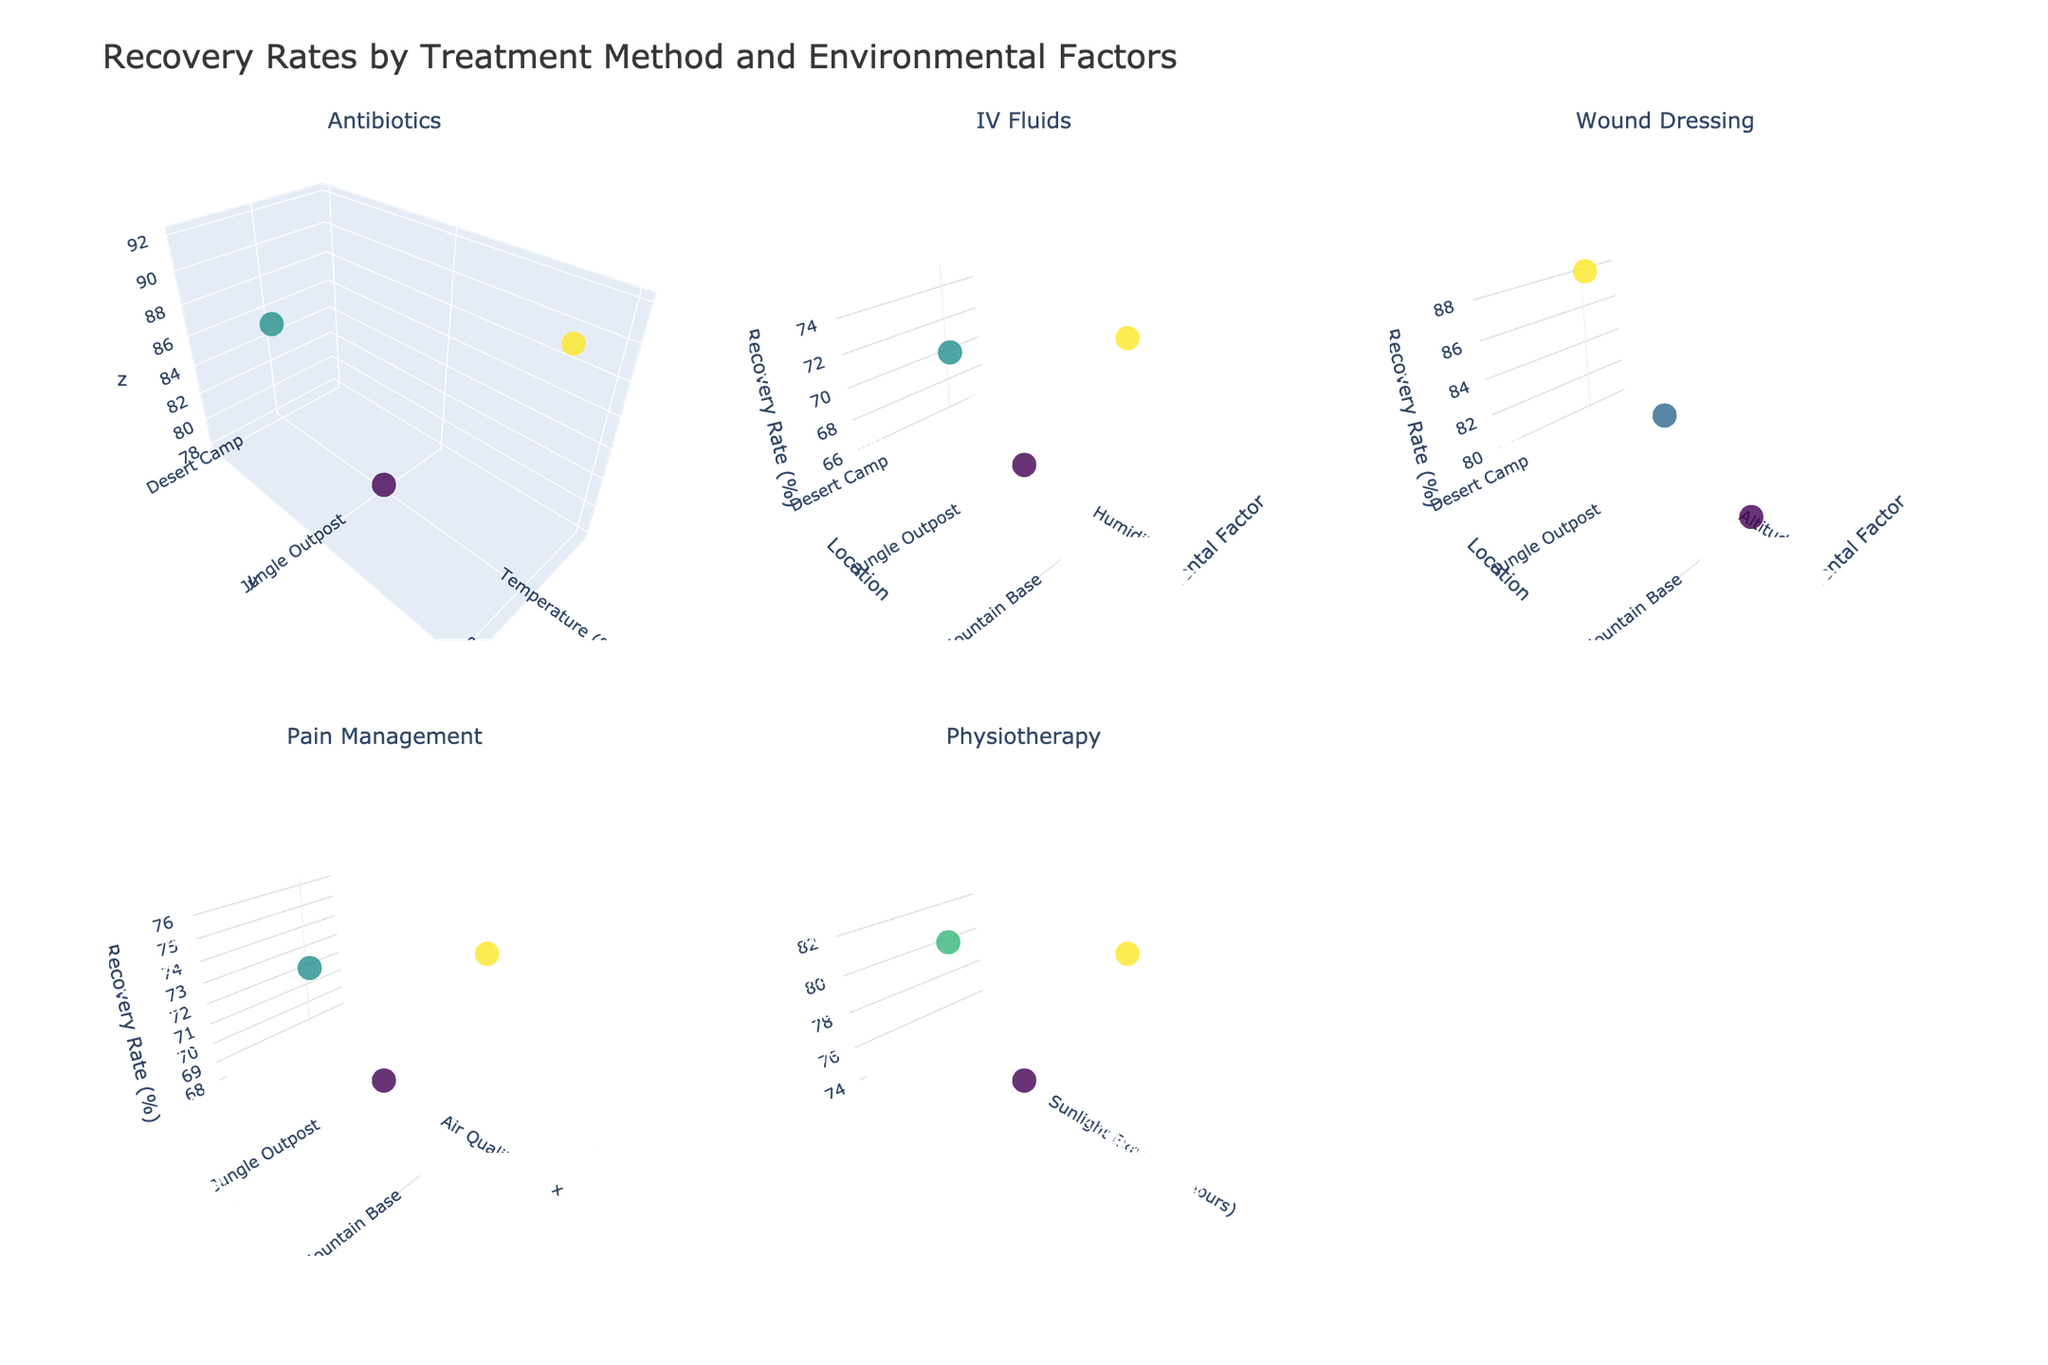What is the title of the plot? The title of the plot is usually displayed at the top of the figure. In this case, it can be found in the layout setting of the figure.
Answer: Recovery Rates by Treatment Method and Environmental Factors How many subplots are present for different treatment methods? The subplots can be identified by their separate scenes and titles. The subplot titles indicate different treatment methods.
Answer: 5 Which environmental factor is associated with the Antibiotics treatment at Jungle Outpost? By looking at the subplot titled 'Antibiotics' for the point labeled Jungle Outpost, we can find the associated environmental factor.
Answer: Temperature (°C) Which treatment method shows the highest recovery rate in the Mountain Base location? By examining each subplot and identifying the highest data point in the Mountain Base location, we can determine which treatment method it corresponds to.
Answer: Antibiotics Compare the recovery rates between Jungle Outpost and Mountain Base for Pain Management. Which location has higher recovery rates? By observing the contrast in z-values on the subplot titled 'Pain Management' between Jungle Outpost and Mountain Base, we can see which is higher.
Answer: Mountain Base What is the average recovery rate across all locations for Physiotherapy? Adding up the recovery rates for Physiotherapy at each location and dividing by the number of locations gives us the average.
Answer: (80 + 74 + 83) / 3 = 79 For IV Fluids, which location has the lowest recovery rate and what is its rate? By comparing the z-values in the IV Fluids subplot, we identify the location with the lowest rate and then check its value.
Answer: Jungle Outpost, 65 Is there any treatment method where all locations have similar recovery rates? By evaluating the spread of data points in each subplot, we can determine if any treatment method shows little variability across locations.
Answer: IV Fluids What is the environmental factor influencing recovery rates in the subplot for Wound Dressing? The environmental factor for the Wound Dressing subplot can be determined by checking the x-axis label of the 3D plot titled 'Wound Dressing'.
Answer: Altitude (m) Which treatment method has the broadest range of recovery rates? By comparing the range of recovery rates (z-axis) across all treatment method subplots, we identify the subplot with the widest range of values.
Answer: Antibiotics 